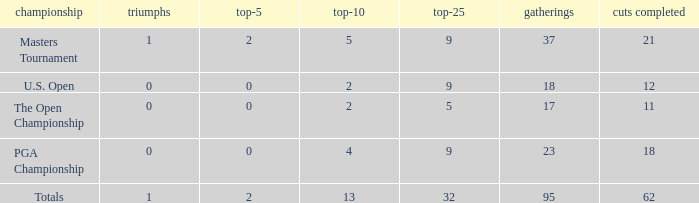What is the average number of cuts made in the Top 25 smaller than 5? None. 